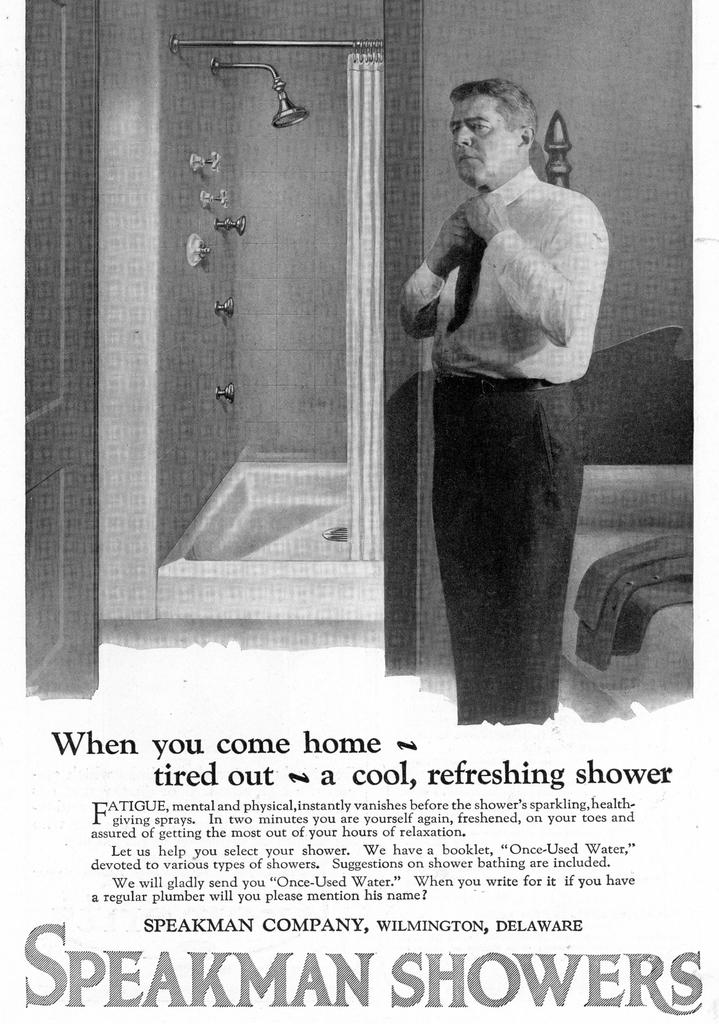<image>
Summarize the visual content of the image. an ad for speakman showers with a man in a tie 